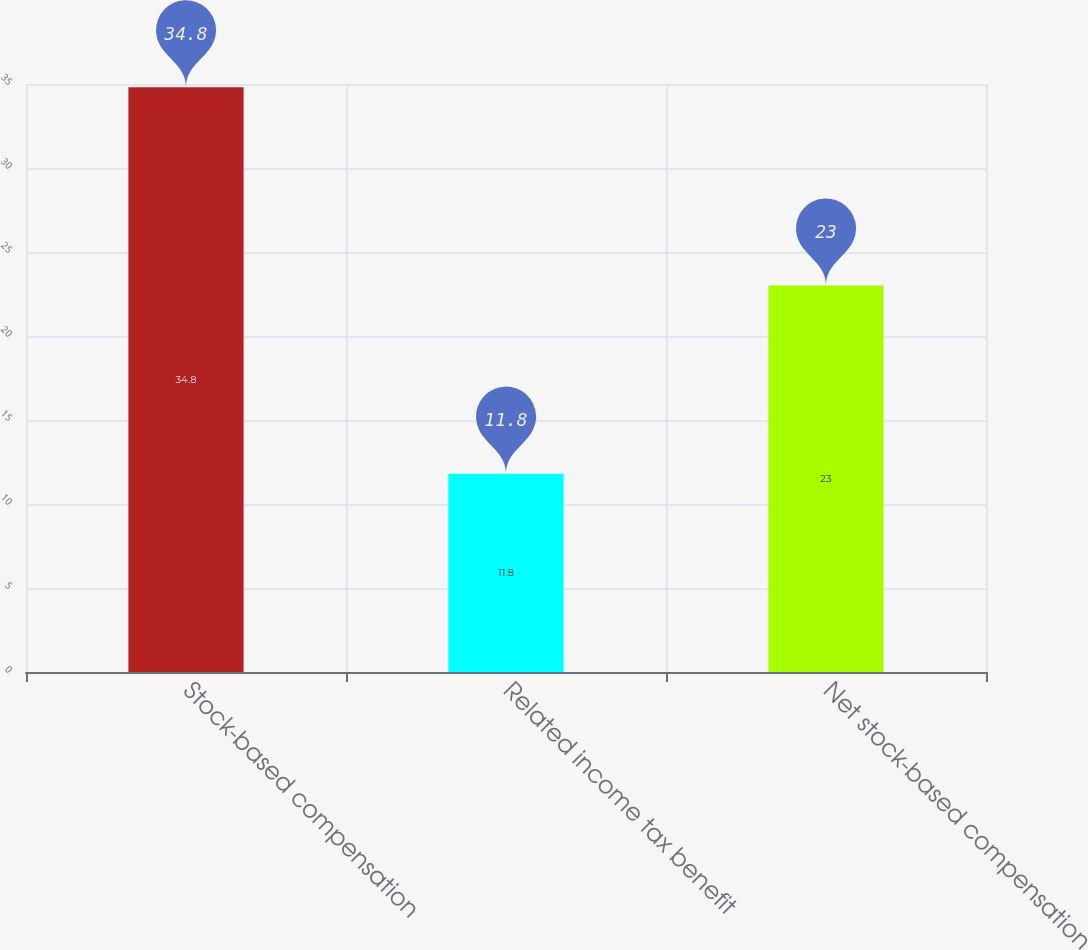Convert chart to OTSL. <chart><loc_0><loc_0><loc_500><loc_500><bar_chart><fcel>Stock-based compensation<fcel>Related income tax benefit<fcel>Net stock-based compensation<nl><fcel>34.8<fcel>11.8<fcel>23<nl></chart> 